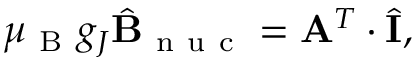Convert formula to latex. <formula><loc_0><loc_0><loc_500><loc_500>\mu _ { B } g _ { J } \hat { B } _ { n u c } = A ^ { T } \cdot \hat { I } ,</formula> 